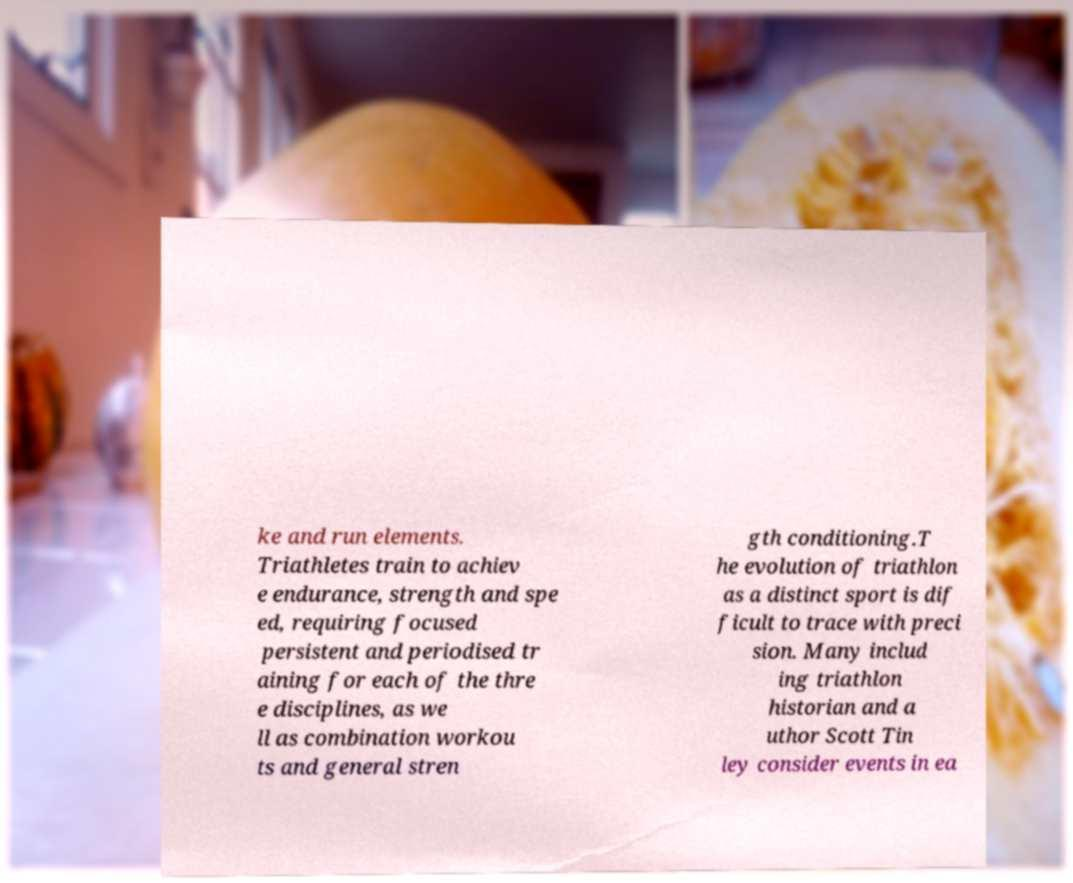What messages or text are displayed in this image? I need them in a readable, typed format. ke and run elements. Triathletes train to achiev e endurance, strength and spe ed, requiring focused persistent and periodised tr aining for each of the thre e disciplines, as we ll as combination workou ts and general stren gth conditioning.T he evolution of triathlon as a distinct sport is dif ficult to trace with preci sion. Many includ ing triathlon historian and a uthor Scott Tin ley consider events in ea 